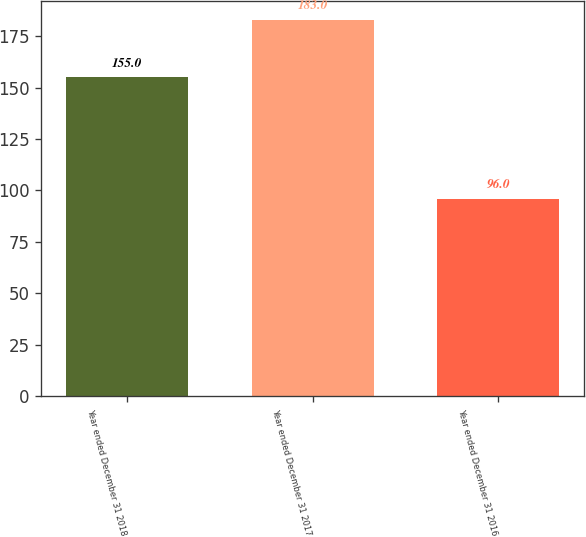Convert chart. <chart><loc_0><loc_0><loc_500><loc_500><bar_chart><fcel>Year ended December 31 2018<fcel>Year ended December 31 2017<fcel>Year ended December 31 2016<nl><fcel>155<fcel>183<fcel>96<nl></chart> 